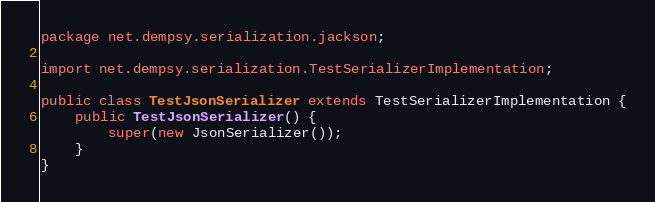Convert code to text. <code><loc_0><loc_0><loc_500><loc_500><_Java_>package net.dempsy.serialization.jackson;

import net.dempsy.serialization.TestSerializerImplementation;

public class TestJsonSerializer extends TestSerializerImplementation {
    public TestJsonSerializer() {
        super(new JsonSerializer());
    }
}
</code> 